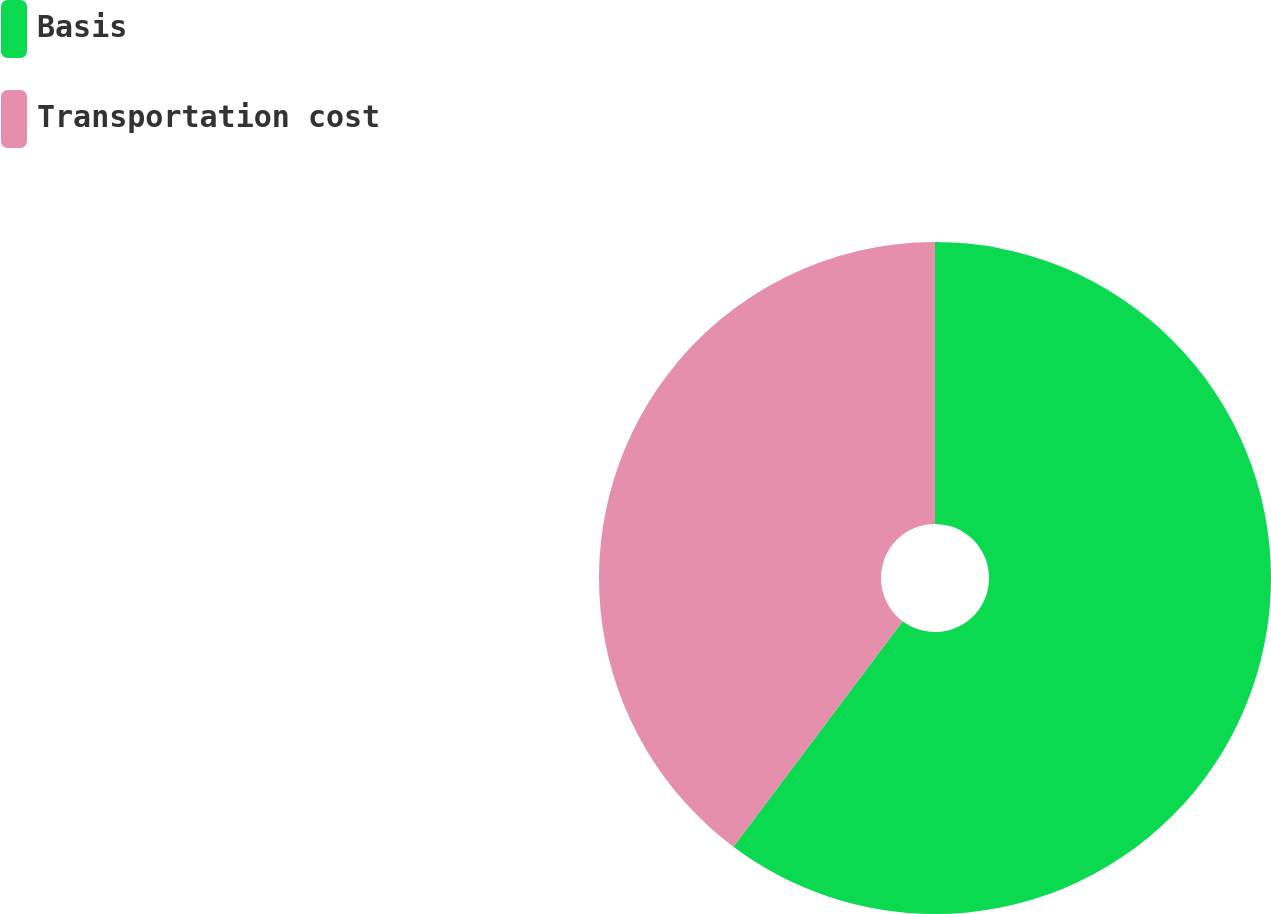<chart> <loc_0><loc_0><loc_500><loc_500><pie_chart><fcel>Basis<fcel>Transportation cost<nl><fcel>60.24%<fcel>39.76%<nl></chart> 